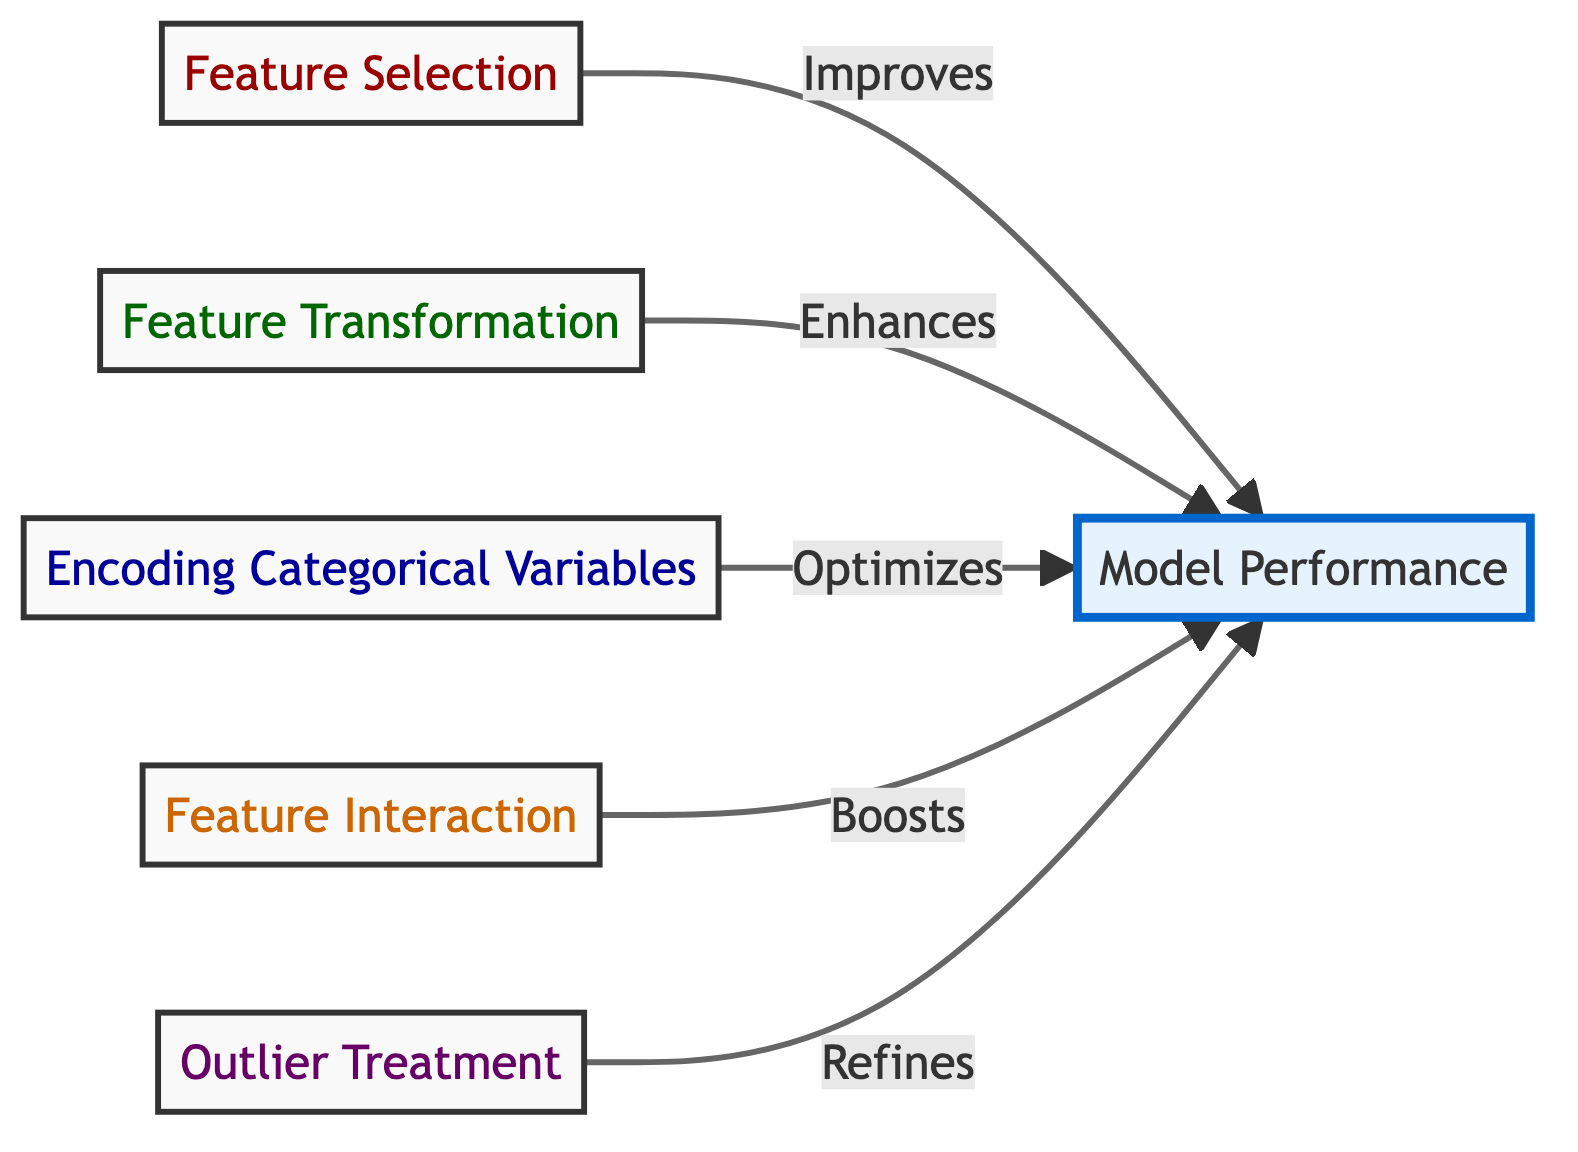What are the nodes in the diagram? The diagram contains five nodes: Feature Selection, Feature Transformation, Encoding Categorical Variables, Feature Interaction, and Outlier Treatment.
Answer: Five nodes How many edges are present in the diagram? There are five edges connecting the techniques to the Model Performance node.
Answer: Five edges Which node directly impacts Model Performance through Feature Selection? The edge from Feature Selection leads directly to Model Performance, indicating its impact on the model's performance.
Answer: Feature Selection What is the relationship between Feature Transformation and Model Performance? The directed edge shows that Feature Transformation enhances Model Performance, indicating a positive influence.
Answer: Enhances Which feature engineering technique is involved in optimizing model performance? The node that mentions optimizing is Encoding Categorical Variables, which suggests it plays a role in improving the model's performance.
Answer: Encoding Categorical Variables Which node does not have a direct edge to Model Performance? All nodes in the diagram have a direct edge leading to Model Performance. Therefore, there are no nodes without a direct edge to it.
Answer: None Which feature engineering technique suggests refinement of feature distribution? The technique associated with refining feature distribution is Outlier Treatment, which indicates its role in improving model performance.
Answer: Outlier Treatment How do Feature Interaction techniques affect Model Performance? The directed edge indicates that Feature Interaction boosts Model Performance, suggesting it contributes positively to the accuracy of the model.
Answer: Boosts What is the common outcome of all the feature engineering techniques listed? All the techniques listed in the diagram ultimately aim to improve Model Performance, showing their collective goal.
Answer: Improve Model Performance 